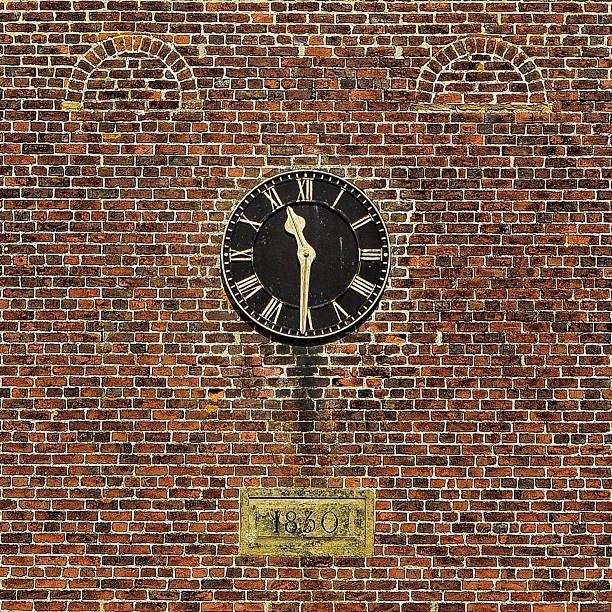Why are there two arches in the brickwork?
Keep it brief. Used to be windows. What time is it?
Keep it brief. 11:30. What is the wall made of?
Be succinct. Brick. 